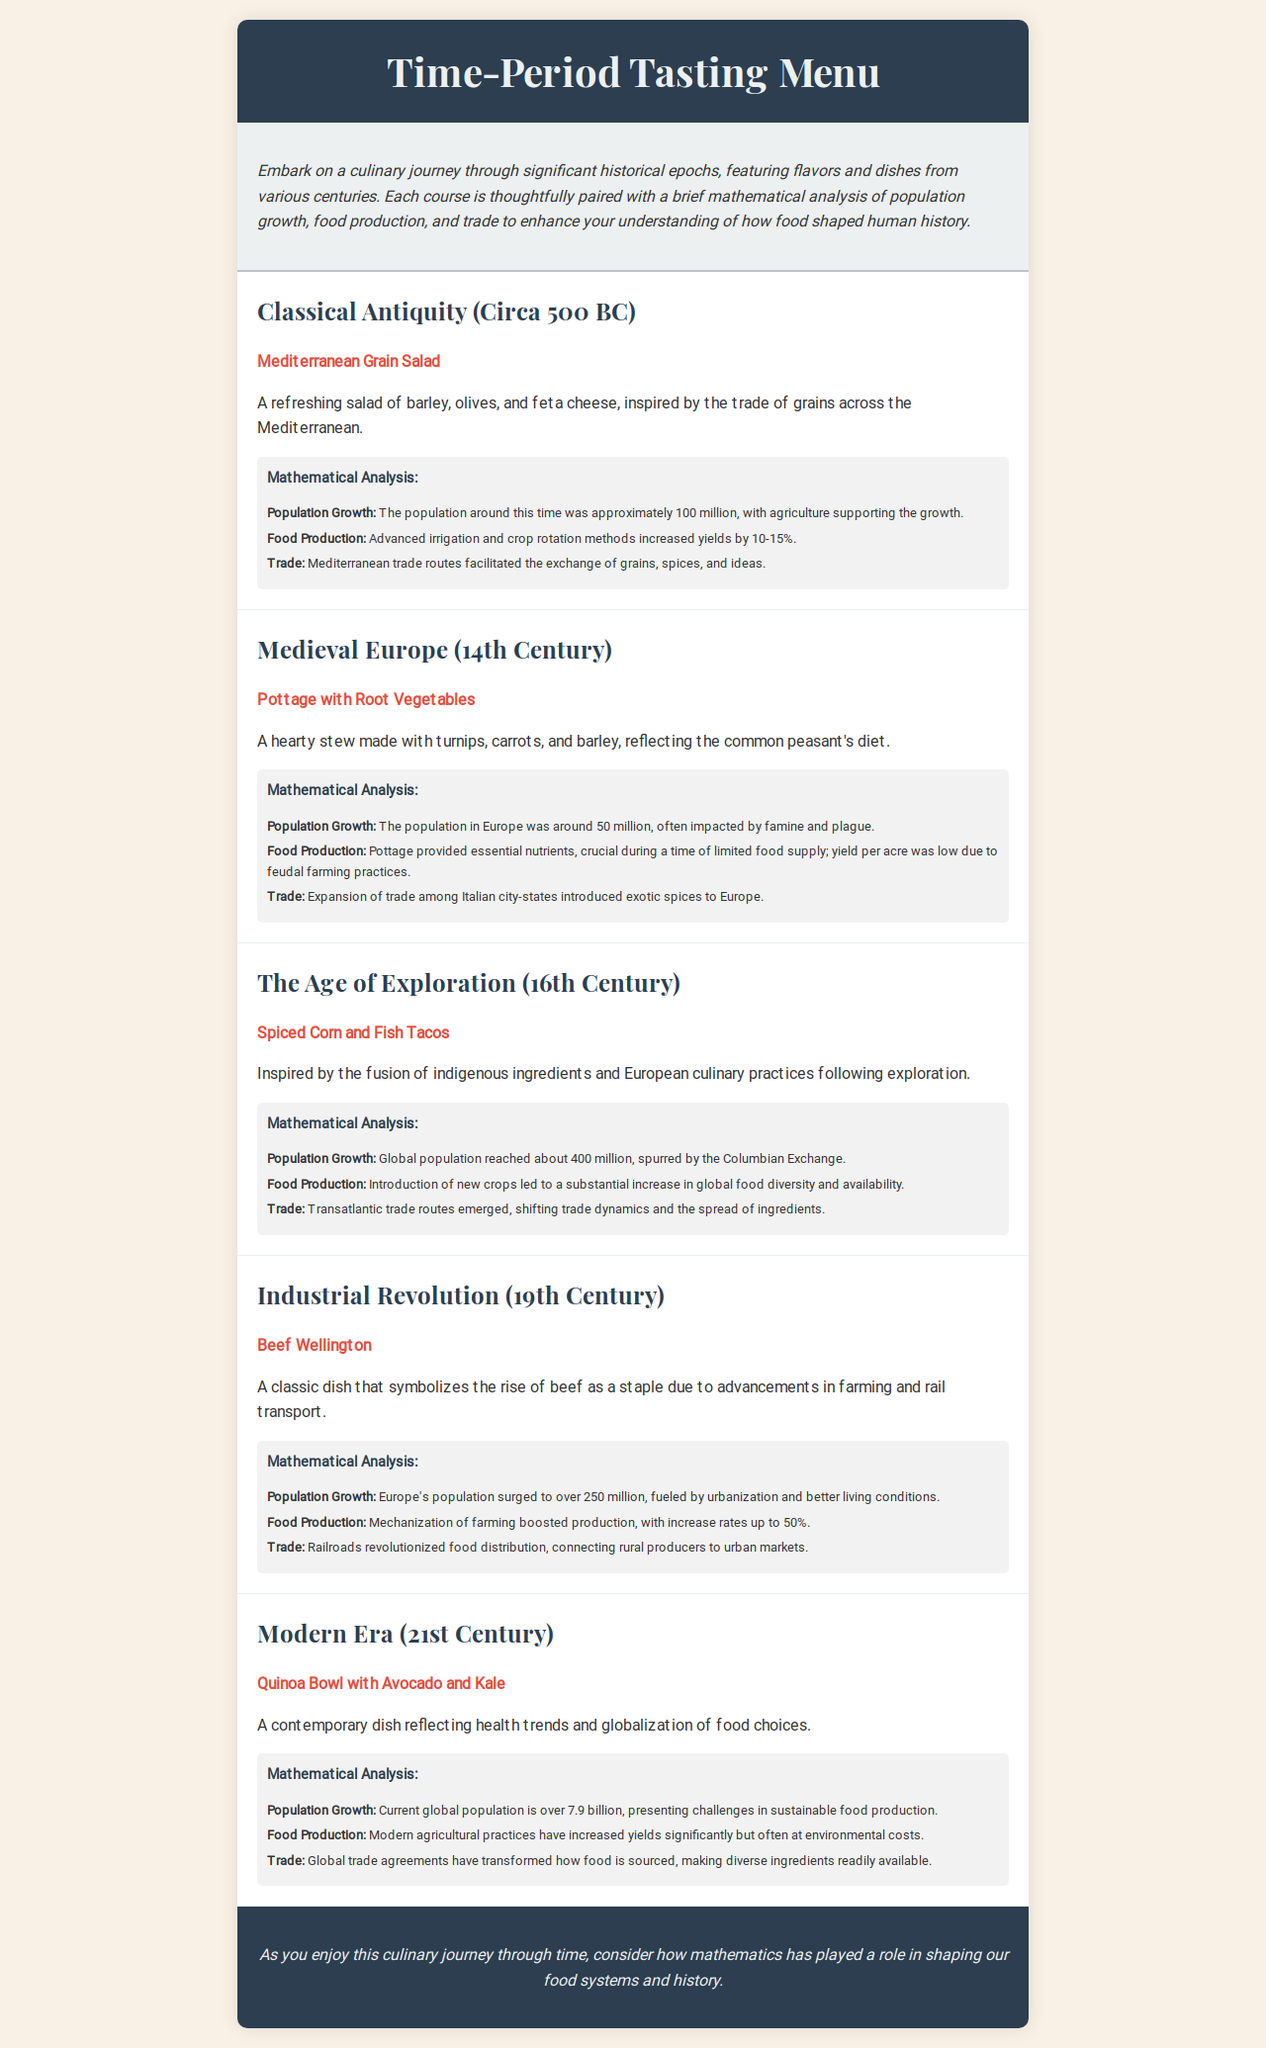What dish is featured in Classical Antiquity? The dish highlighted in Classical Antiquity is Mediterranean Grain Salad.
Answer: Mediterranean Grain Salad What was the global population in the 16th Century? The document states that the global population reached about 400 million during the Age of Exploration.
Answer: 400 million What primary ingredient is used in the dish representing the Industrial Revolution? The dish Beef Wellington primarily symbolizes the rise of beef as a staple due to advancements in farming.
Answer: Beef What agricultural feature increased yields by 10-15% in Classical Antiquity? The mathematical analysis mentions that advanced irrigation and crop rotation methods increased yields.
Answer: Advanced irrigation and crop rotation How did the population of Europe shift during the 19th Century? The document indicates that Europe's population surged to over 250 million during the Industrial Revolution.
Answer: Over 250 million What is the modern dish representing health trends? The dish from the 21st Century reflecting health trends is Quinoa Bowl with Avocado and Kale.
Answer: Quinoa Bowl with Avocado and Kale What trade routes emerged during the Age of Exploration? The text notes that transatlantic trade routes emerged during the Age of Exploration.
Answer: Transatlantic trade routes Which century had the population impacted by famine and plague? The document indicates that the Medieval Europe (14th Century) population was affected by famine and plague.
Answer: 14th Century 